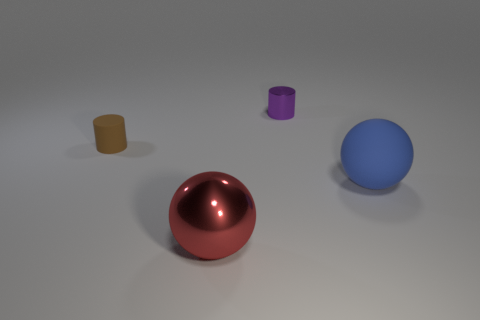Is the material of the purple cylinder the same as the small brown object?
Your response must be concise. No. What number of matte things are big red objects or big green balls?
Make the answer very short. 0. What shape is the matte object on the right side of the purple shiny thing?
Your response must be concise. Sphere. What is the size of the object that is made of the same material as the brown cylinder?
Your response must be concise. Large. The thing that is in front of the metallic cylinder and behind the big blue matte ball has what shape?
Provide a short and direct response. Cylinder. There is a small thing that is right of the tiny brown object; does it have the same color as the tiny rubber cylinder?
Offer a very short reply. No. There is a large thing on the left side of the big matte sphere; is it the same shape as the matte object on the left side of the blue rubber thing?
Give a very brief answer. No. There is a shiny object that is behind the red metal ball; what size is it?
Your answer should be compact. Small. There is a matte thing behind the rubber object right of the brown cylinder; what is its size?
Make the answer very short. Small. Are there more small gray rubber objects than purple things?
Your response must be concise. No. 